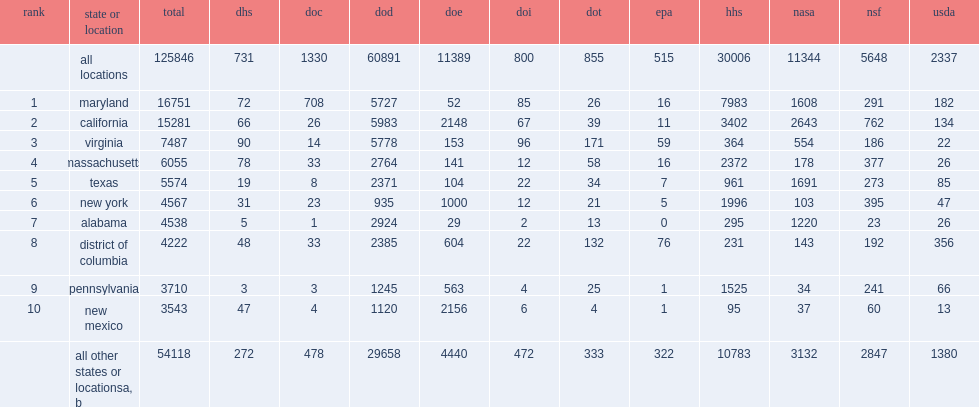How many million dollars in maryland, home of hhs's national institutes of health (nih), was the top state recipient? 16751.0. How many milliond dollars in california which was the second highest recipient? 15281.0. Which million dollars in virginia which ranked third, receiving in federal r&d obligations? 7487.0. 